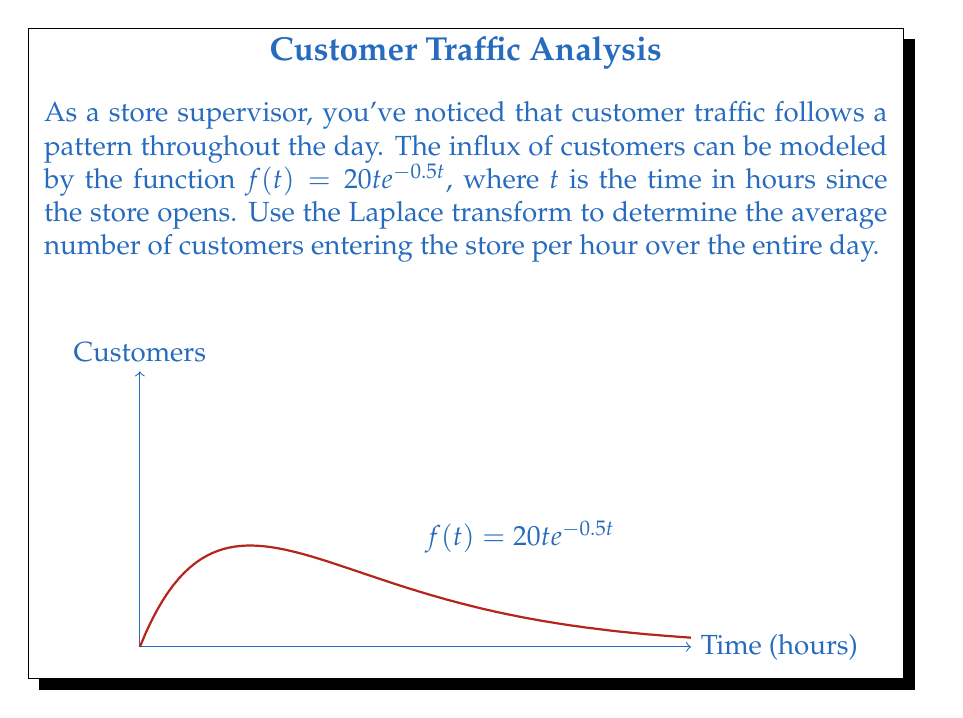Can you answer this question? Let's approach this step-by-step:

1) The Laplace transform of $f(t) = 20t e^{-0.5t}$ is given by:

   $$F(s) = \mathcal{L}\{f(t)\} = \int_0^{\infty} 20t e^{-0.5t} e^{-st} dt$$

2) This is a standard form. The Laplace transform of $t e^{-at}$ is $\frac{1}{(s+a)^2}$. Here, $a = 0.5$.

3) Therefore, 
   
   $$F(s) = \frac{20}{(s+0.5)^2}$$

4) To find the average over the entire day, we need to evaluate $\lim_{s \to 0} sF(s)$:

   $$\lim_{s \to 0} sF(s) = \lim_{s \to 0} \frac{20s}{(s+0.5)^2}$$

5) Apply L'Hôpital's rule:

   $$\lim_{s \to 0} \frac{20}{2(s+0.5)} = \frac{20}{2(0.5)} = 20$$

6) Therefore, the average number of customers entering the store per hour over the entire day is 20.

This method utilizes the Final Value Theorem of Laplace transforms, which states that for a well-behaved function $f(t)$, $\lim_{t \to \infty} f(t) = \lim_{s \to 0} sF(s)$.
Answer: 20 customers per hour 